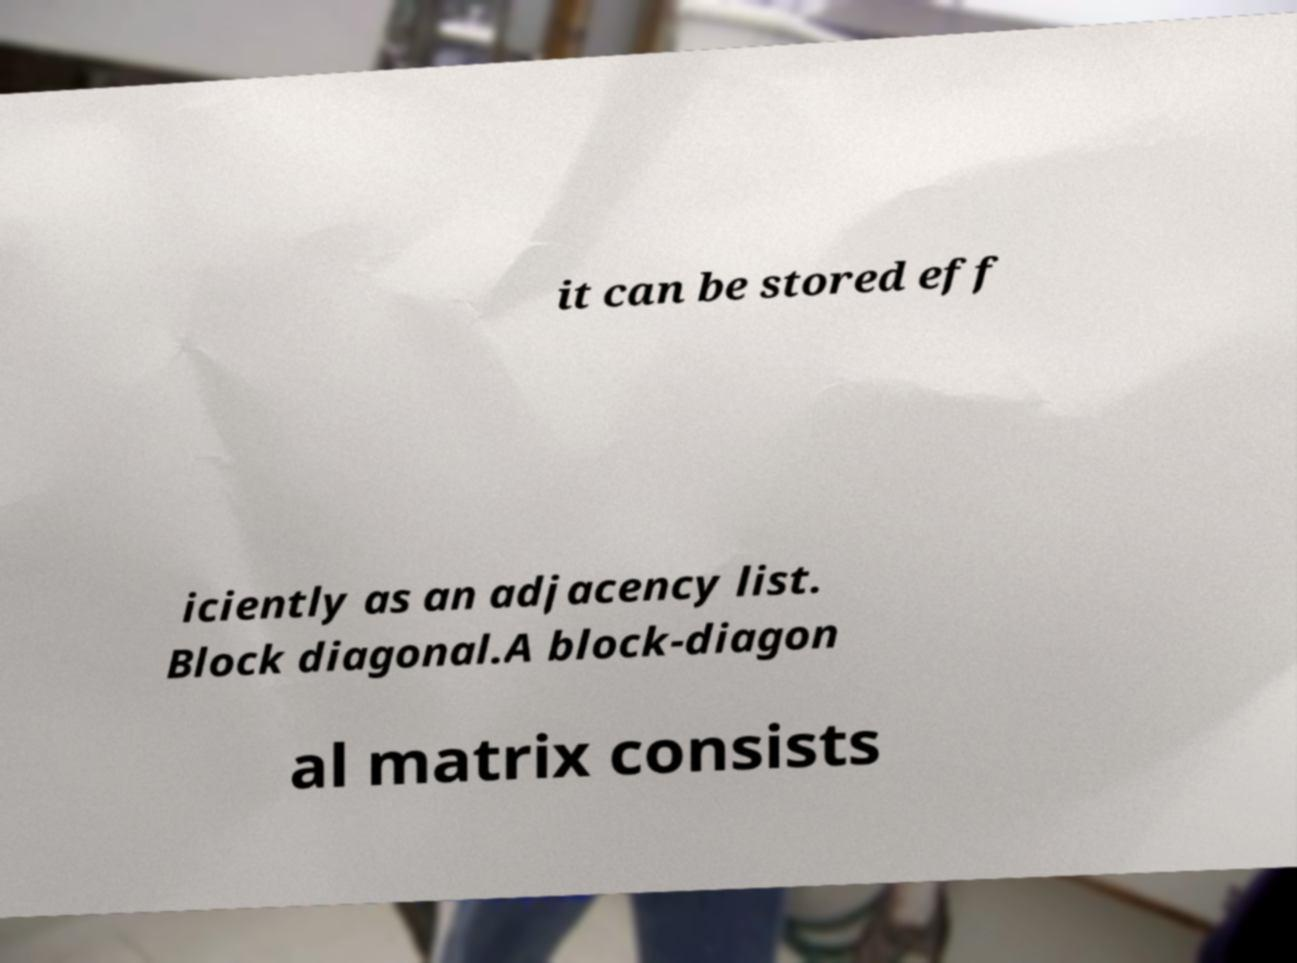Can you read and provide the text displayed in the image?This photo seems to have some interesting text. Can you extract and type it out for me? it can be stored eff iciently as an adjacency list. Block diagonal.A block-diagon al matrix consists 